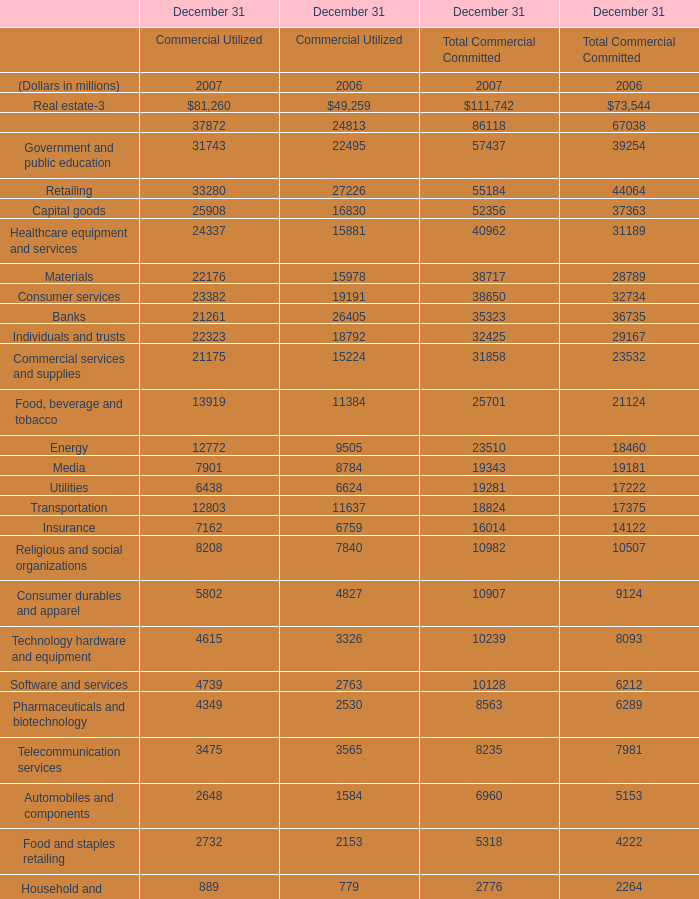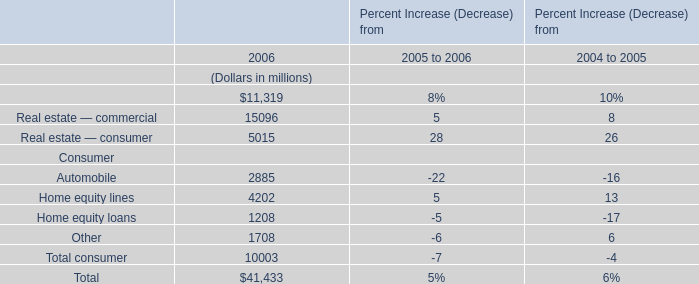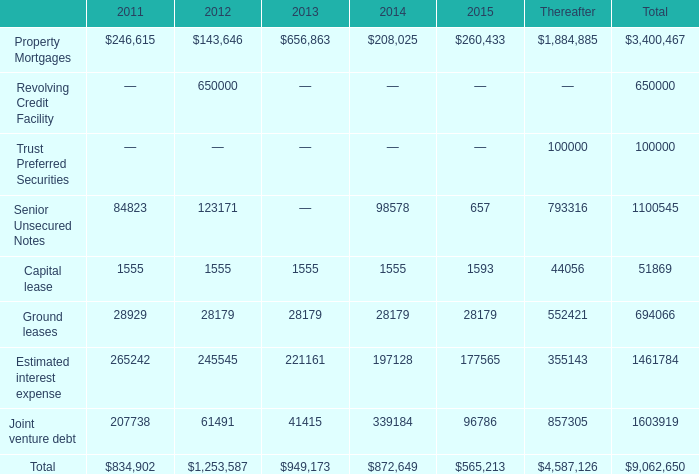what's the total amount of Ground leases of 2012, Food, beverage and tobacco of December 31 Commercial Utilized 2007, and Senior Unsecured Notes of 2012 ? 
Computations: ((28179.0 + 13919.0) + 123171.0)
Answer: 165269.0. 